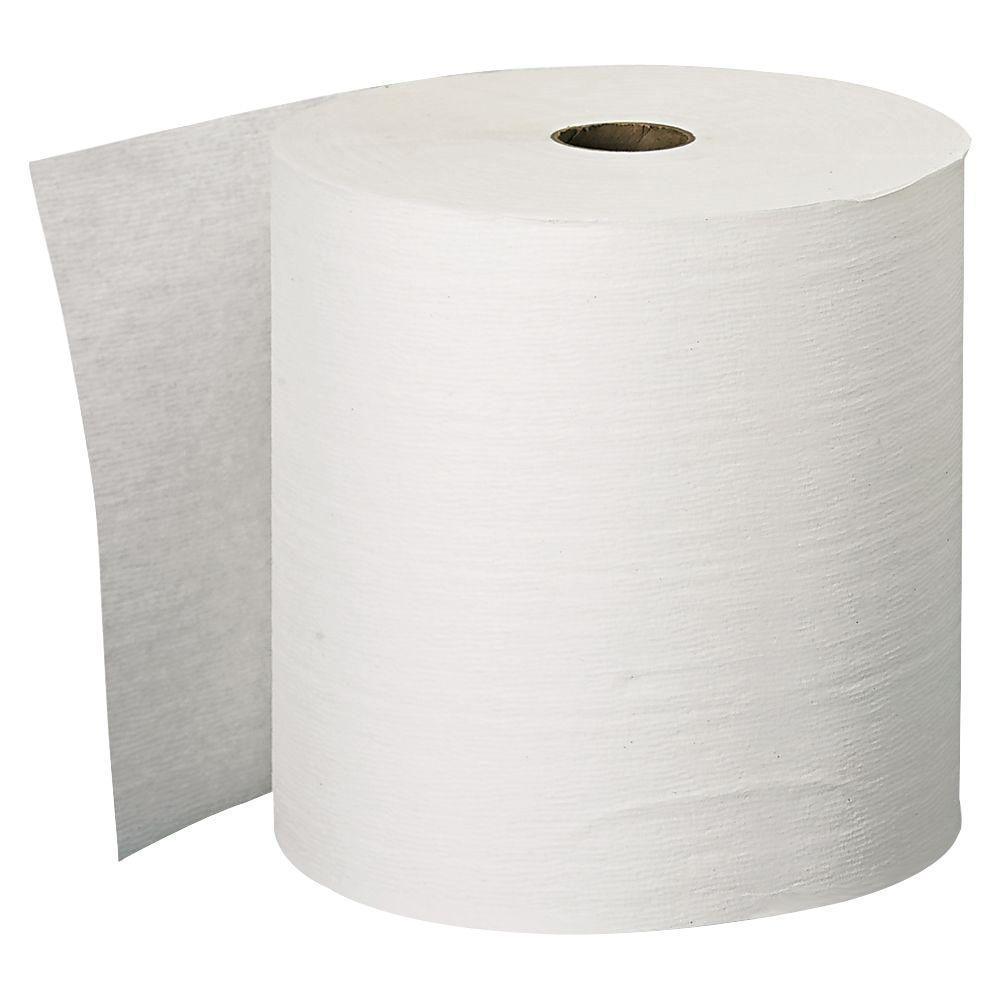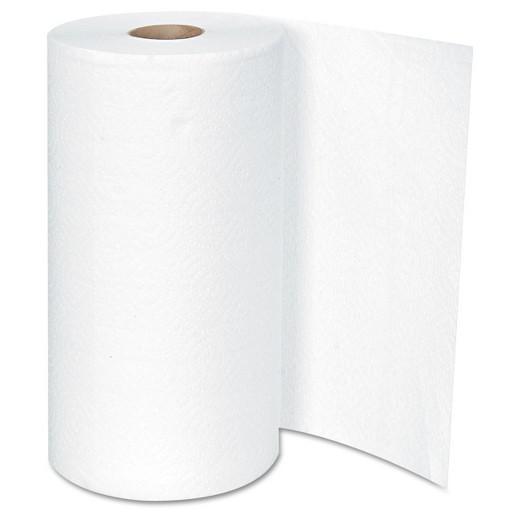The first image is the image on the left, the second image is the image on the right. For the images displayed, is the sentence "One of the images show some type of paper towel dispenser." factually correct? Answer yes or no. No. The first image is the image on the left, the second image is the image on the right. For the images shown, is this caption "An image shows a roll of towels on an upright stand with a chrome part that extends out of the top." true? Answer yes or no. No. 